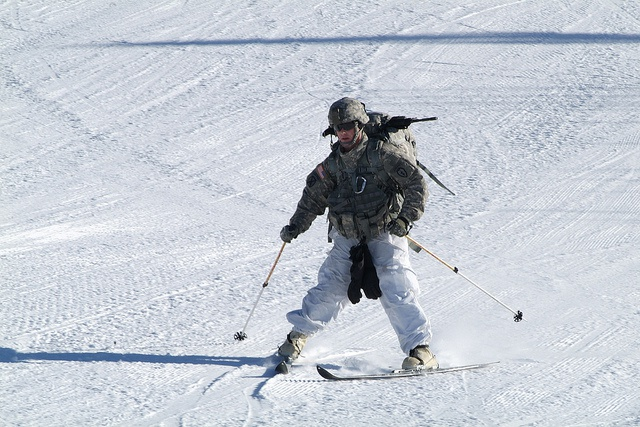Describe the objects in this image and their specific colors. I can see people in lightgray, black, gray, and darkgray tones, backpack in lightgray, black, darkgray, and gray tones, and skis in lightgray, darkgray, black, and gray tones in this image. 